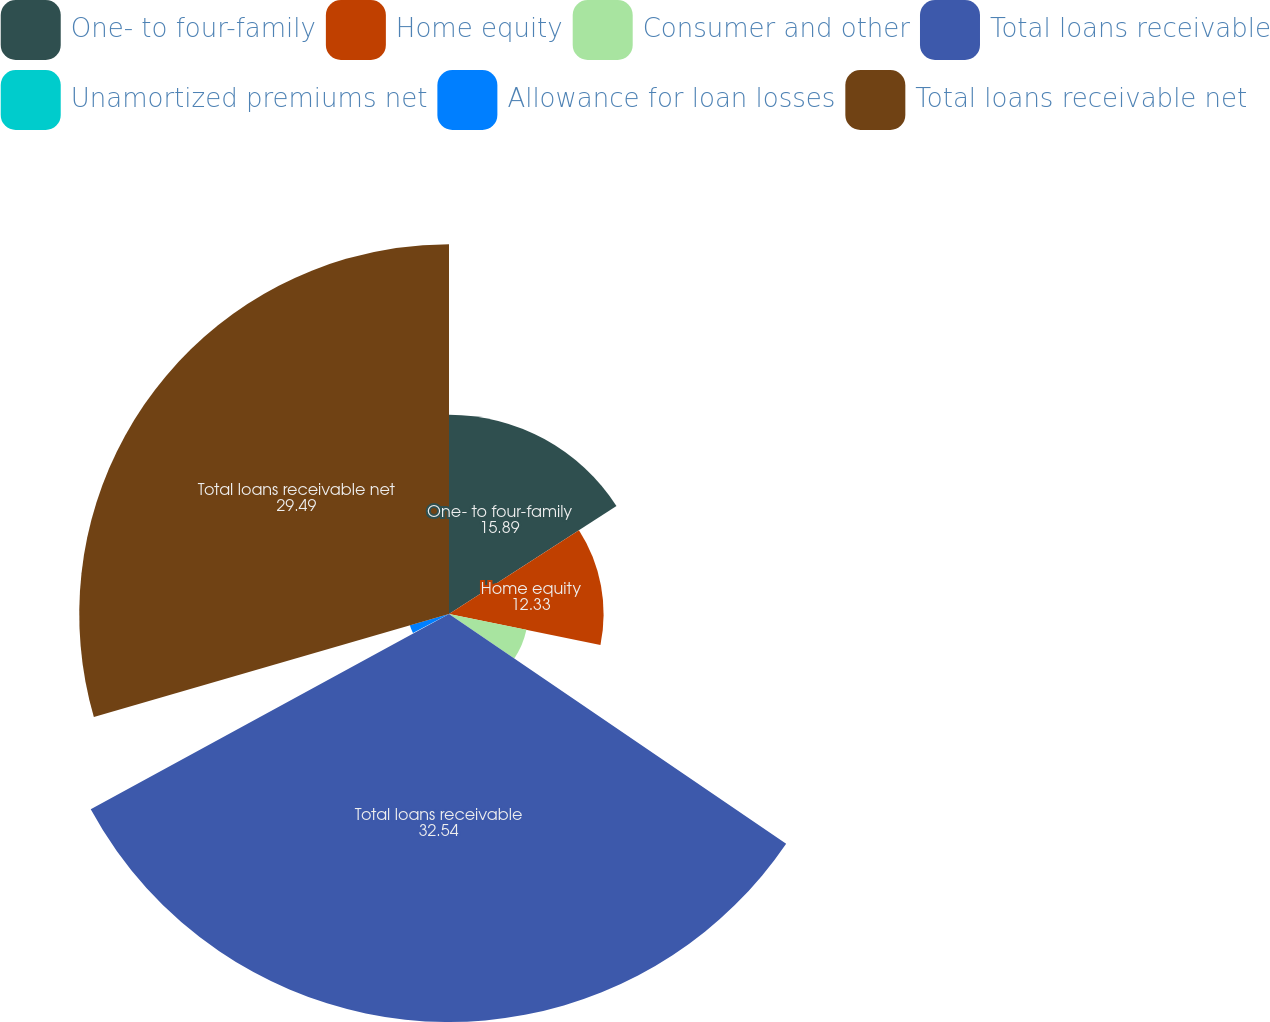Convert chart. <chart><loc_0><loc_0><loc_500><loc_500><pie_chart><fcel>One- to four-family<fcel>Home equity<fcel>Consumer and other<fcel>Total loans receivable<fcel>Unamortized premiums net<fcel>Allowance for loan losses<fcel>Total loans receivable net<nl><fcel>15.89%<fcel>12.33%<fcel>6.3%<fcel>32.54%<fcel>0.2%<fcel>3.25%<fcel>29.49%<nl></chart> 